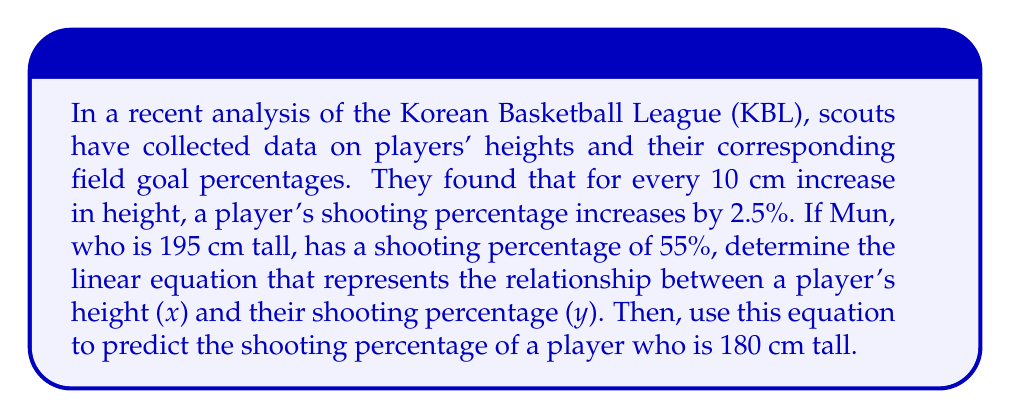Show me your answer to this math problem. Let's approach this step-by-step:

1) First, we need to identify the slope and y-intercept of the linear equation.

2) The slope (m) represents the rate of change:
   For every 10 cm increase in height, the shooting percentage increases by 2.5%
   $m = \frac{2.5\%}{10 \text{ cm}} = 0.25\% \text{ per cm} = 0.0025 \text{ per cm}$

3) Now, we can use the point-slope form of a linear equation:
   $y - y_1 = m(x - x_1)$
   Where $(x_1, y_1)$ is the known point (Mun's data): (195, 55)

4) Substituting our values:
   $y - 55 = 0.0025(x - 195)$

5) Simplify:
   $y - 55 = 0.0025x - 0.4875$
   $y = 0.0025x - 0.4875 + 55$
   $y = 0.0025x + 54.5125$

6) This is our linear equation: $y = 0.0025x + 54.5125$

7) To predict the shooting percentage of a player who is 180 cm tall, we substitute x = 180:
   $y = 0.0025(180) + 54.5125$
   $y = 0.45 + 54.5125$
   $y = 54.9625\%$

Therefore, a player who is 180 cm tall is predicted to have a shooting percentage of approximately 54.96%.
Answer: $y = 0.0025x + 54.5125$; 54.96% 